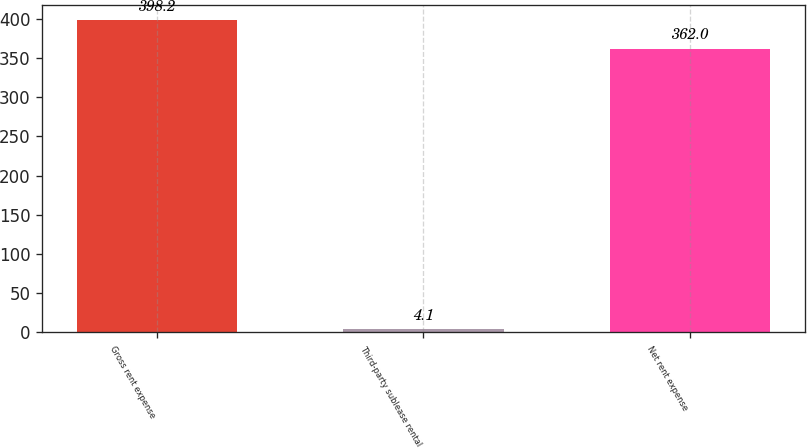<chart> <loc_0><loc_0><loc_500><loc_500><bar_chart><fcel>Gross rent expense<fcel>Third-party sublease rental<fcel>Net rent expense<nl><fcel>398.2<fcel>4.1<fcel>362<nl></chart> 